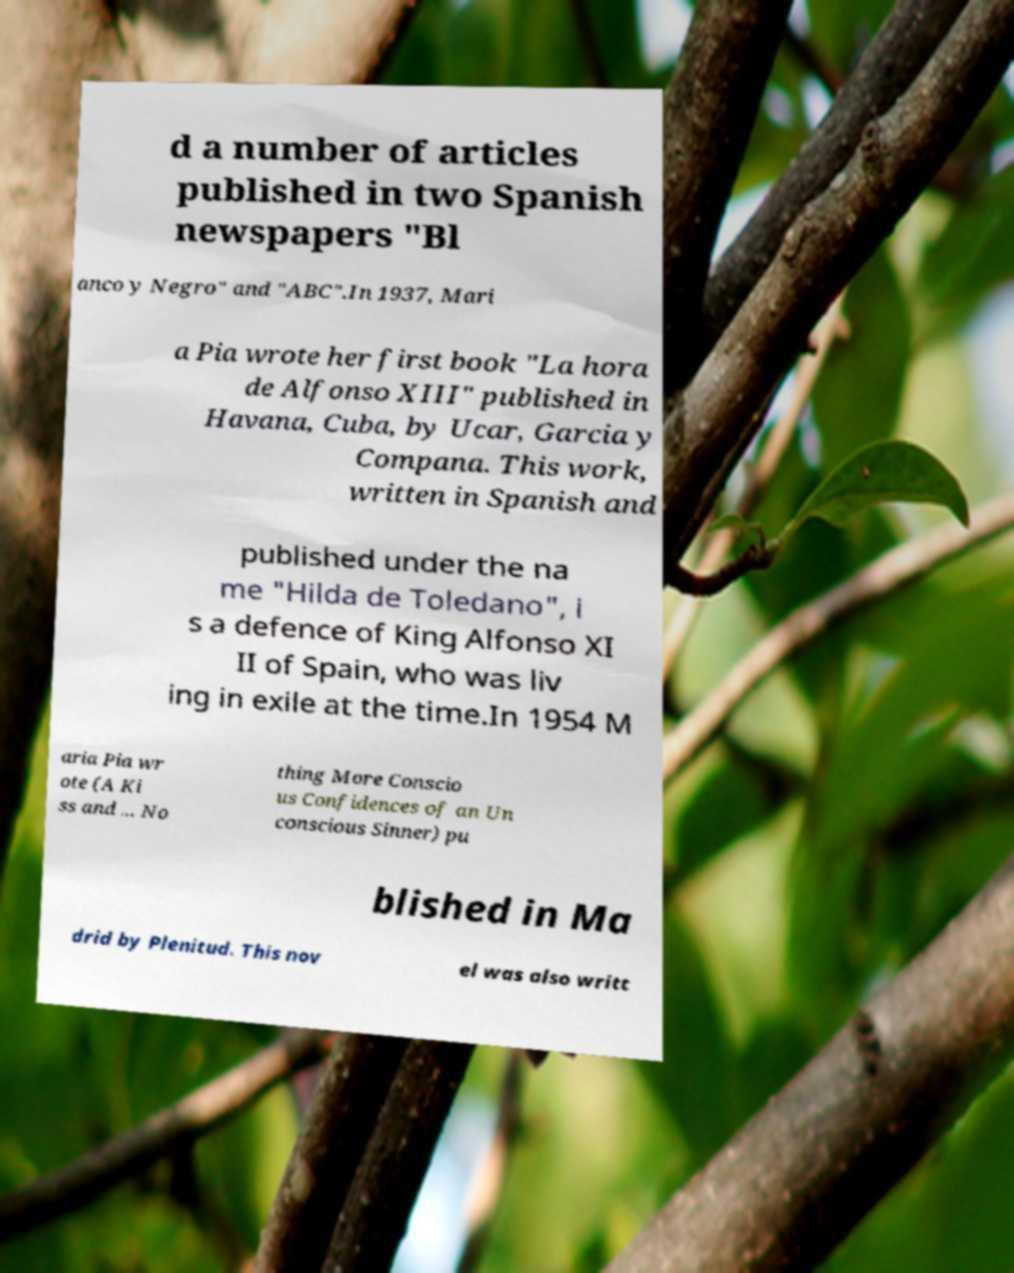For documentation purposes, I need the text within this image transcribed. Could you provide that? d a number of articles published in two Spanish newspapers "Bl anco y Negro" and "ABC".In 1937, Mari a Pia wrote her first book "La hora de Alfonso XIII" published in Havana, Cuba, by Ucar, Garcia y Compana. This work, written in Spanish and published under the na me "Hilda de Toledano", i s a defence of King Alfonso XI II of Spain, who was liv ing in exile at the time.In 1954 M aria Pia wr ote (A Ki ss and ... No thing More Conscio us Confidences of an Un conscious Sinner) pu blished in Ma drid by Plenitud. This nov el was also writt 